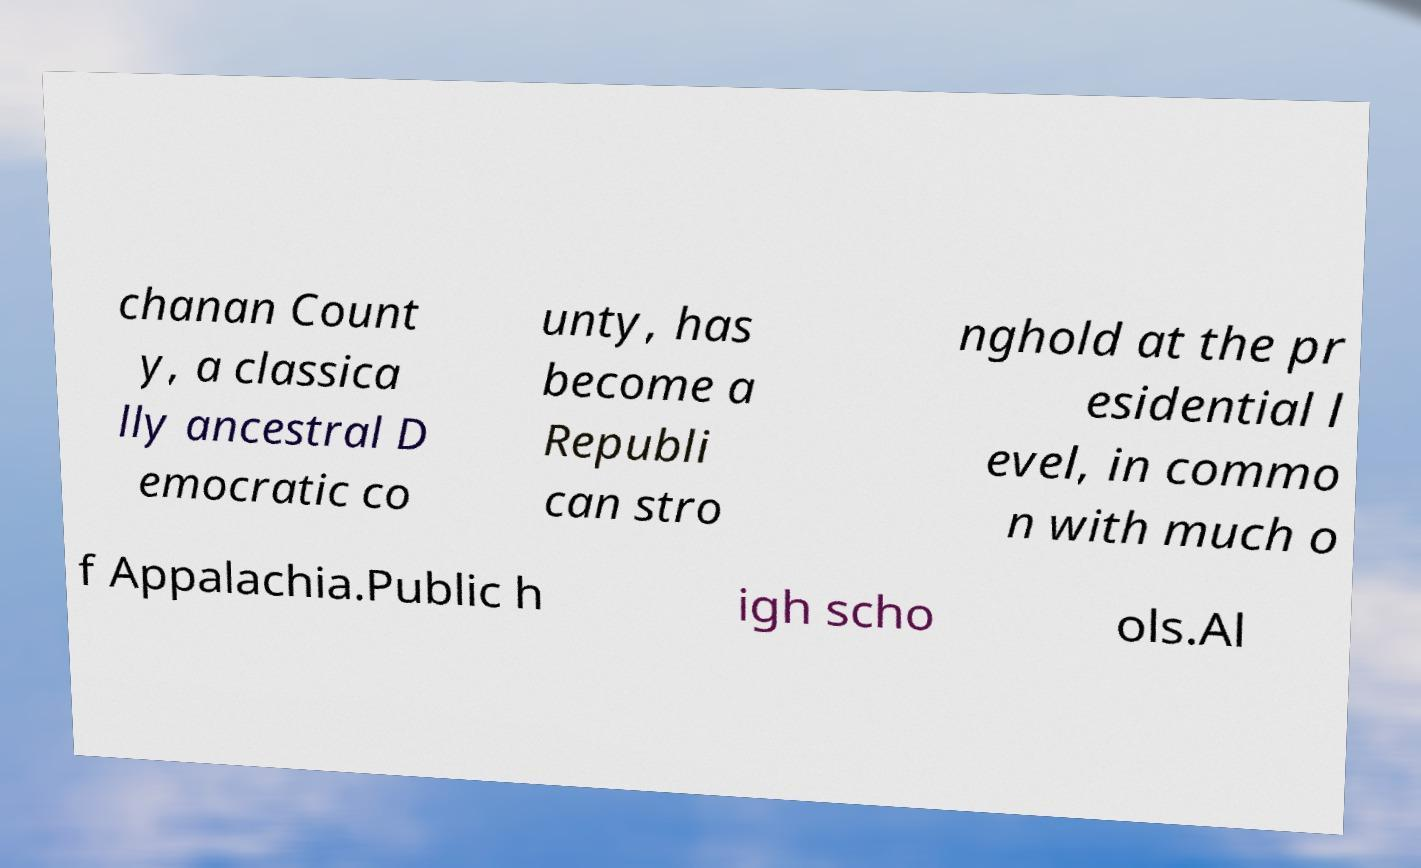Can you accurately transcribe the text from the provided image for me? chanan Count y, a classica lly ancestral D emocratic co unty, has become a Republi can stro nghold at the pr esidential l evel, in commo n with much o f Appalachia.Public h igh scho ols.Al 